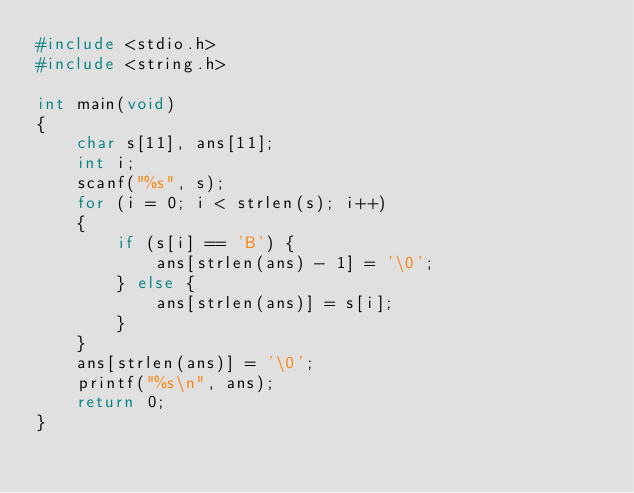Convert code to text. <code><loc_0><loc_0><loc_500><loc_500><_C_>#include <stdio.h>
#include <string.h>

int main(void)
{
    char s[11], ans[11];
    int i;
    scanf("%s", s);
    for (i = 0; i < strlen(s); i++)
    {
        if (s[i] == 'B') {
            ans[strlen(ans) - 1] = '\0';
        } else {
            ans[strlen(ans)] = s[i];
        }
    }
    ans[strlen(ans)] = '\0';
    printf("%s\n", ans);
    return 0;
}</code> 